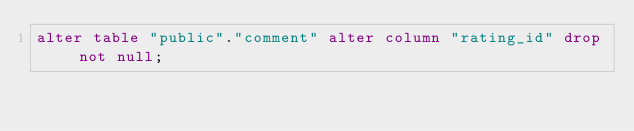Convert code to text. <code><loc_0><loc_0><loc_500><loc_500><_SQL_>alter table "public"."comment" alter column "rating_id" drop not null;
</code> 